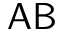<formula> <loc_0><loc_0><loc_500><loc_500>A B</formula> 